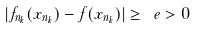<formula> <loc_0><loc_0><loc_500><loc_500>| f _ { n _ { k } } ( x _ { n _ { k } } ) - f ( x _ { n _ { k } } ) | \geq \ e > 0 \,</formula> 